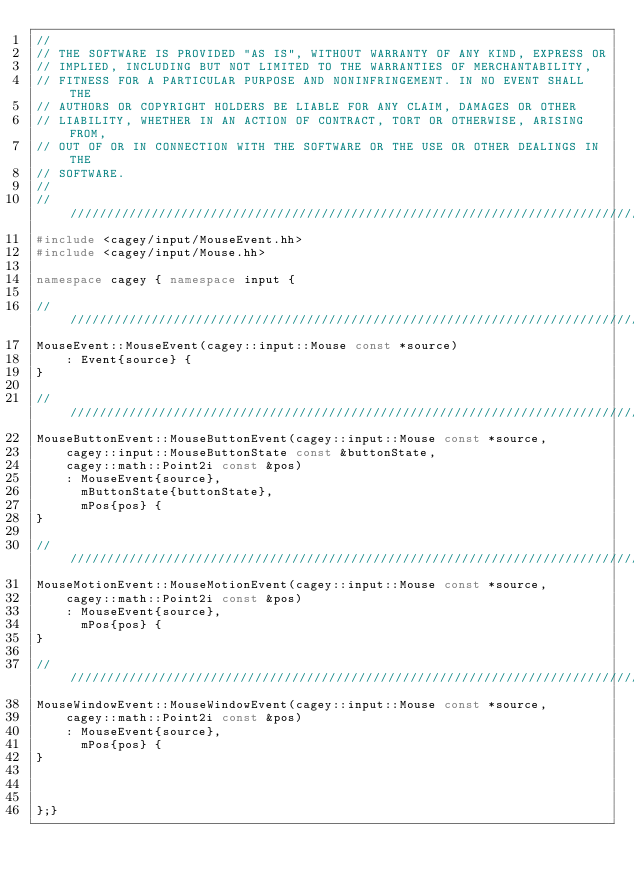<code> <loc_0><loc_0><loc_500><loc_500><_C++_>//
// THE SOFTWARE IS PROVIDED "AS IS", WITHOUT WARRANTY OF ANY KIND, EXPRESS OR
// IMPLIED, INCLUDING BUT NOT LIMITED TO THE WARRANTIES OF MERCHANTABILITY,
// FITNESS FOR A PARTICULAR PURPOSE AND NONINFRINGEMENT. IN NO EVENT SHALL THE
// AUTHORS OR COPYRIGHT HOLDERS BE LIABLE FOR ANY CLAIM, DAMAGES OR OTHER
// LIABILITY, WHETHER IN AN ACTION OF CONTRACT, TORT OR OTHERWISE, ARISING FROM,
// OUT OF OR IN CONNECTION WITH THE SOFTWARE OR THE USE OR OTHER DEALINGS IN THE
// SOFTWARE.
//
////////////////////////////////////////////////////////////////////////////////
#include <cagey/input/MouseEvent.hh>
#include <cagey/input/Mouse.hh>

namespace cagey { namespace input {

///////////////////////////////////////////////////////////////////////////////
MouseEvent::MouseEvent(cagey::input::Mouse const *source)
    : Event{source} {
}

///////////////////////////////////////////////////////////////////////////////
MouseButtonEvent::MouseButtonEvent(cagey::input::Mouse const *source,
    cagey::input::MouseButtonState const &buttonState,
    cagey::math::Point2i const &pos)
    : MouseEvent{source},
      mButtonState{buttonState},
      mPos{pos} {
}

///////////////////////////////////////////////////////////////////////////////
MouseMotionEvent::MouseMotionEvent(cagey::input::Mouse const *source,
    cagey::math::Point2i const &pos)
    : MouseEvent{source},
      mPos{pos} {
}

///////////////////////////////////////////////////////////////////////////////
MouseWindowEvent::MouseWindowEvent(cagey::input::Mouse const *source,
    cagey::math::Point2i const &pos)
    : MouseEvent{source},
      mPos{pos} {
}



};}</code> 